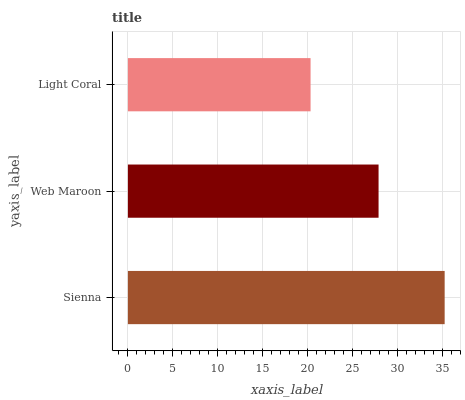Is Light Coral the minimum?
Answer yes or no. Yes. Is Sienna the maximum?
Answer yes or no. Yes. Is Web Maroon the minimum?
Answer yes or no. No. Is Web Maroon the maximum?
Answer yes or no. No. Is Sienna greater than Web Maroon?
Answer yes or no. Yes. Is Web Maroon less than Sienna?
Answer yes or no. Yes. Is Web Maroon greater than Sienna?
Answer yes or no. No. Is Sienna less than Web Maroon?
Answer yes or no. No. Is Web Maroon the high median?
Answer yes or no. Yes. Is Web Maroon the low median?
Answer yes or no. Yes. Is Light Coral the high median?
Answer yes or no. No. Is Light Coral the low median?
Answer yes or no. No. 